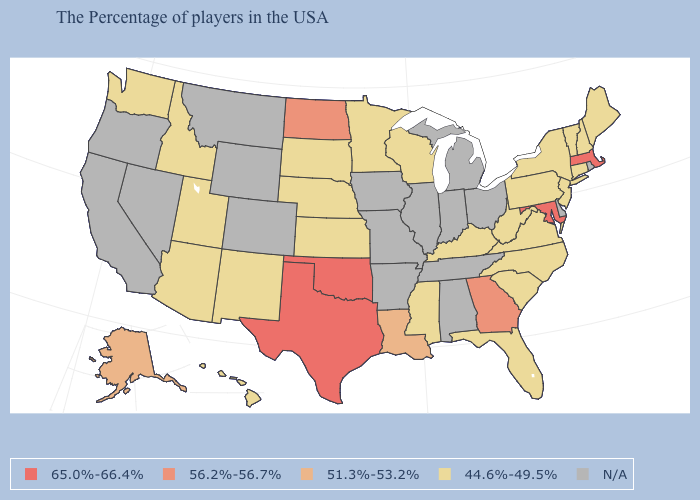Name the states that have a value in the range 65.0%-66.4%?
Answer briefly. Massachusetts, Maryland, Oklahoma, Texas. What is the value of Washington?
Be succinct. 44.6%-49.5%. What is the value of South Carolina?
Give a very brief answer. 44.6%-49.5%. Name the states that have a value in the range 51.3%-53.2%?
Be succinct. Louisiana, Alaska. Among the states that border Montana , does Idaho have the highest value?
Keep it brief. No. Which states have the lowest value in the USA?
Keep it brief. Maine, New Hampshire, Vermont, Connecticut, New York, New Jersey, Pennsylvania, Virginia, North Carolina, South Carolina, West Virginia, Florida, Kentucky, Wisconsin, Mississippi, Minnesota, Kansas, Nebraska, South Dakota, New Mexico, Utah, Arizona, Idaho, Washington, Hawaii. Does New Mexico have the lowest value in the West?
Answer briefly. Yes. Name the states that have a value in the range 44.6%-49.5%?
Quick response, please. Maine, New Hampshire, Vermont, Connecticut, New York, New Jersey, Pennsylvania, Virginia, North Carolina, South Carolina, West Virginia, Florida, Kentucky, Wisconsin, Mississippi, Minnesota, Kansas, Nebraska, South Dakota, New Mexico, Utah, Arizona, Idaho, Washington, Hawaii. Name the states that have a value in the range 51.3%-53.2%?
Quick response, please. Louisiana, Alaska. What is the highest value in the USA?
Give a very brief answer. 65.0%-66.4%. Name the states that have a value in the range N/A?
Quick response, please. Rhode Island, Delaware, Ohio, Michigan, Indiana, Alabama, Tennessee, Illinois, Missouri, Arkansas, Iowa, Wyoming, Colorado, Montana, Nevada, California, Oregon. Does New Hampshire have the lowest value in the Northeast?
Answer briefly. Yes. What is the value of Idaho?
Keep it brief. 44.6%-49.5%. Does North Dakota have the lowest value in the USA?
Answer briefly. No. Does the map have missing data?
Short answer required. Yes. 